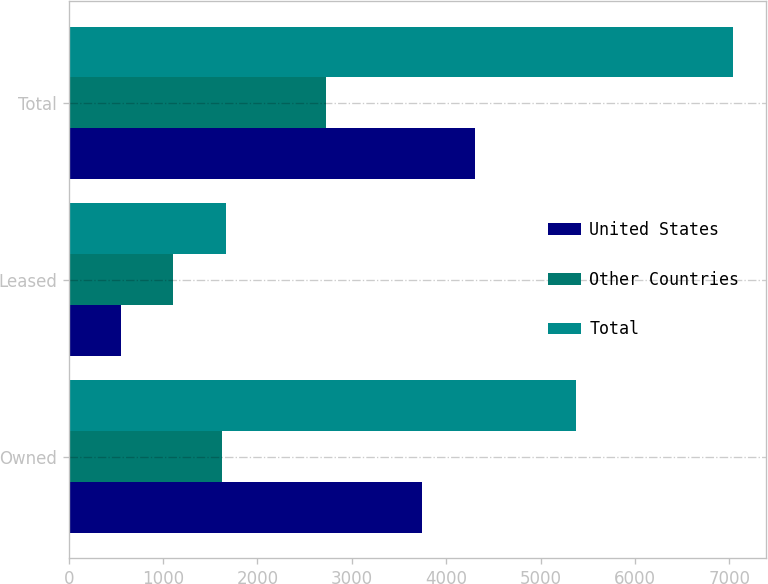Convert chart. <chart><loc_0><loc_0><loc_500><loc_500><stacked_bar_chart><ecel><fcel>Owned<fcel>Leased<fcel>Total<nl><fcel>United States<fcel>3748<fcel>556<fcel>4304<nl><fcel>Other Countries<fcel>1624<fcel>1107<fcel>2731<nl><fcel>Total<fcel>5372<fcel>1663<fcel>7035<nl></chart> 